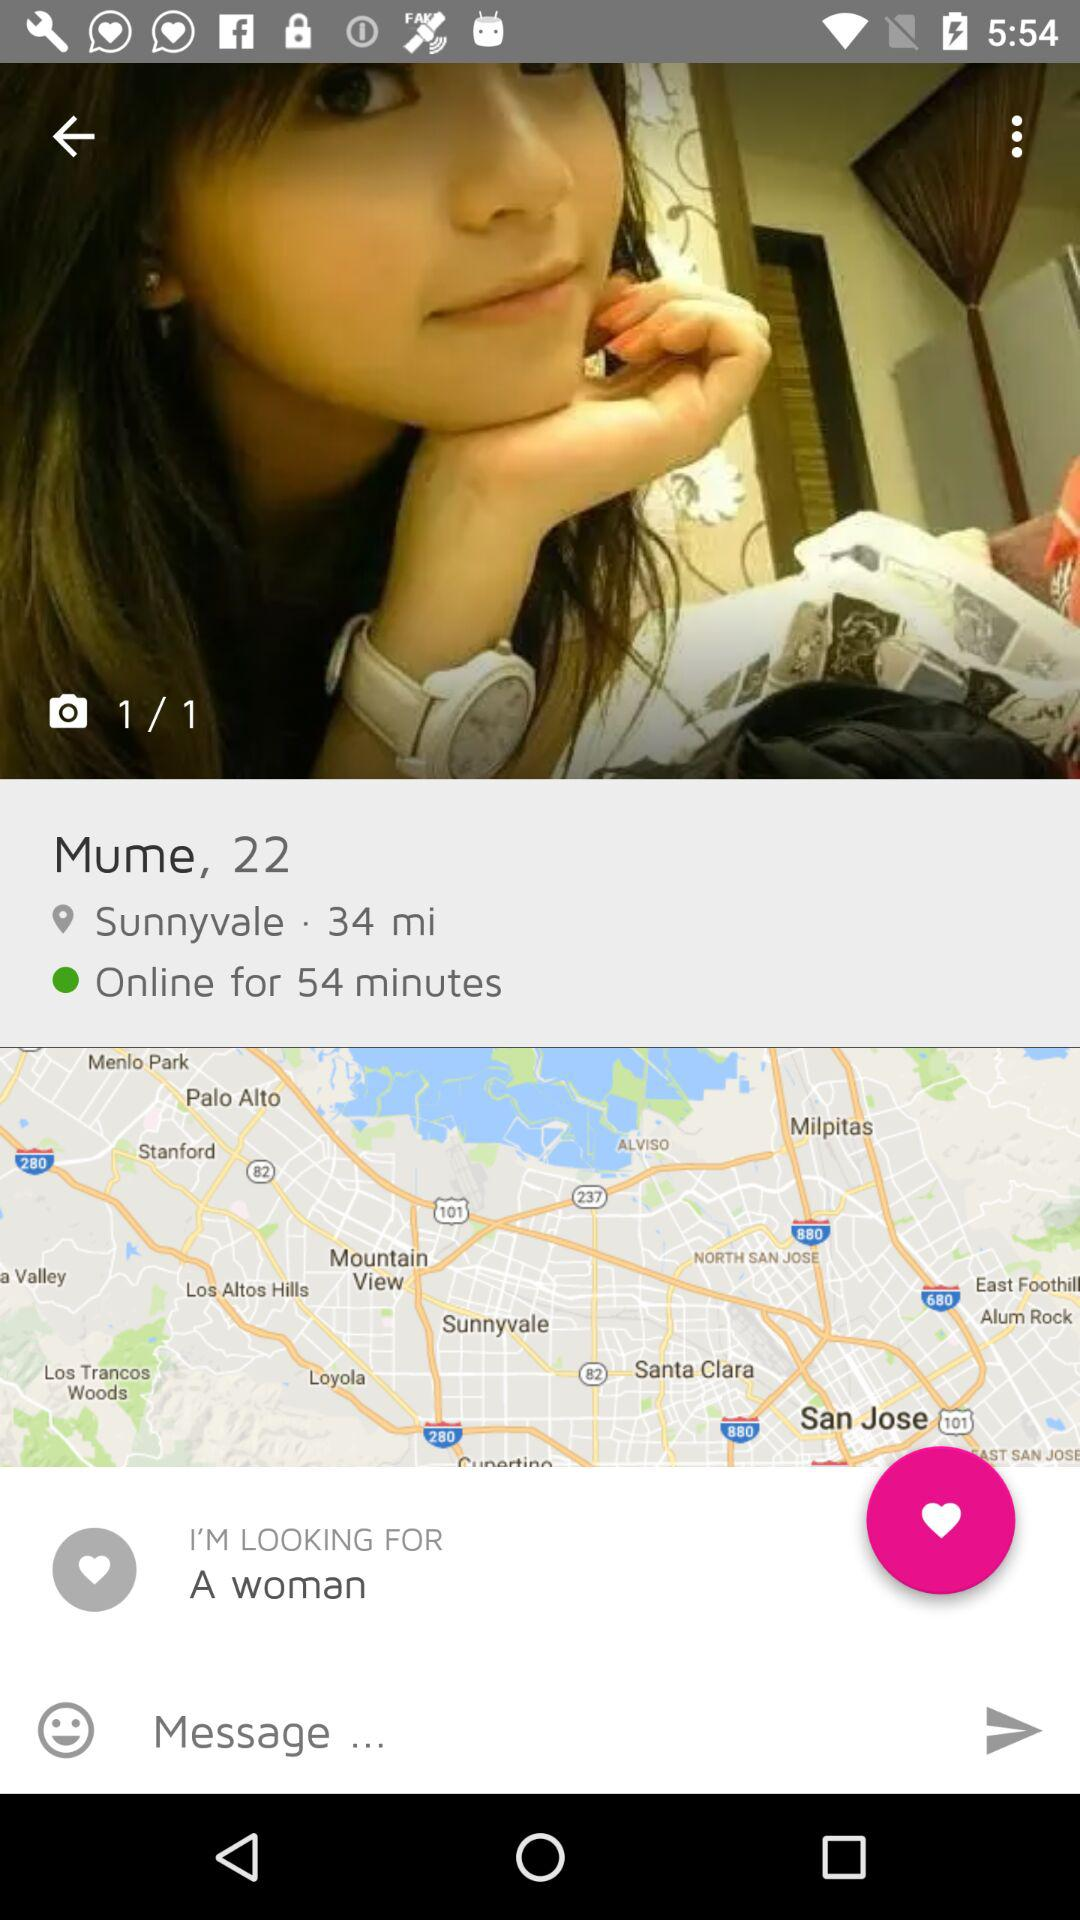What is the user name? The user name is Mume. 